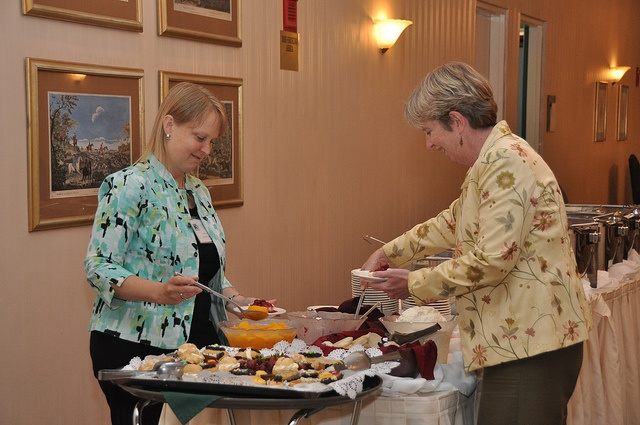Describe the objects in this image and their specific colors. I can see people in gray, tan, and black tones, people in gray, darkgray, and black tones, dining table in gray, black, darkgray, and maroon tones, dining table in gray, black, maroon, and tan tones, and bowl in gray, red, and orange tones in this image. 